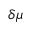Convert formula to latex. <formula><loc_0><loc_0><loc_500><loc_500>\delta \mu</formula> 